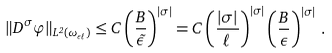Convert formula to latex. <formula><loc_0><loc_0><loc_500><loc_500>\| D ^ { \sigma } \varphi \| _ { L ^ { 2 } ( \omega _ { \epsilon \ell } ) } \leq C \left ( \frac { B } { \tilde { \epsilon } } \right ) ^ { | \sigma | } = C \left ( \frac { | \sigma | } { \ell } \right ) ^ { | \sigma | } \left ( \frac { B } { \epsilon } \right ) ^ { | \sigma | } \, .</formula> 